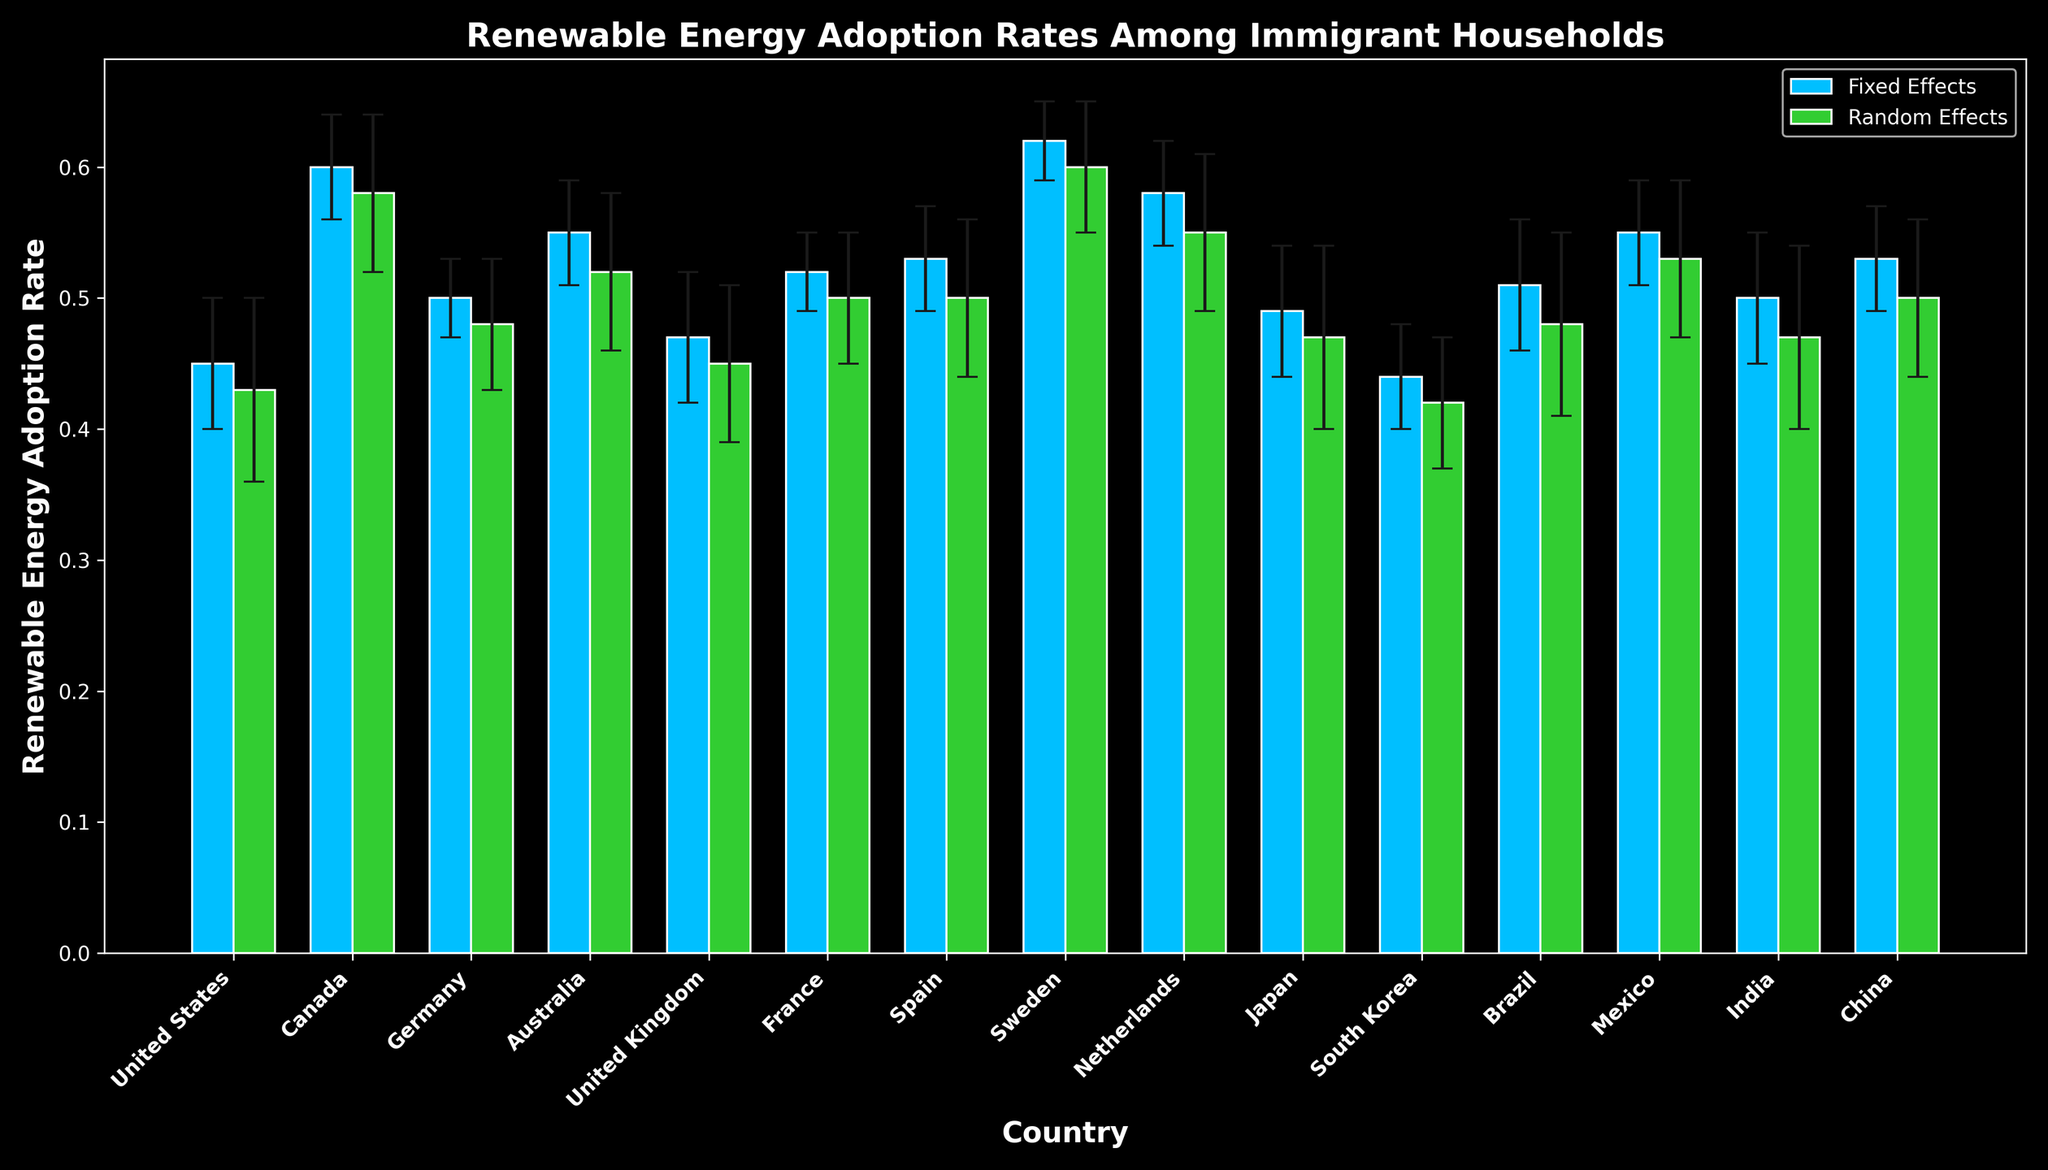Which country has the highest renewable energy adoption rate among immigrant households according to the fixed effects model? By looking at the heights of the blue bars representing the fixed effects model, Sweden has the highest bar around 0.62 according to the fixed effects model.
Answer: Sweden Which country has the smallest difference in renewable energy adoption rate between the fixed effects and random effects models? The differences between the bars can be observed, and Canada has the smallest difference as the fixed effects adoption rate is 0.60 and the random effects adoption rate is 0.58, giving a difference of 0.02.
Answer: Canada Between France and Germany, which country has a higher adoption rate according to the random effects model? Looking at the heights of the green bars for France and Germany, France has a slightly higher adoption rate of 0.50 compared to Germany's 0.48 in the random effects model.
Answer: France Calculate the average fixed effects adoption rate for Canada, Germany, and Australia. The fixed effects rates for Canada, Germany, and Australia are 0.60, 0.50, and 0.55 respectively. The average is (0.60 + 0.50 + 0.55) / 3 = 0.55.
Answer: 0.55 How does the error margin for the fixed effects model for Sweden compare to the error margin for the random effects model for the United States? The error margin for Sweden's fixed effects model is 0.03 and for the United States' random effects model is 0.07. By comparing these values, it is clear that Sweden's fixed effects model has a smaller error margin.
Answer: Sweden's fixed effects model has a smaller error margin Which country shows the largest difference in error margins between the fixed effects and random effects models? By examining the data, the United States shows the largest difference in error margins: fixed effects error is 0.05 and random effects error is 0.07, giving a difference of 0.02.
Answer: United States Among Mexico, China, and India, which country has the highest average adoption rate across both models? The average adoption rates can be calculated: Mexico (0.55 + 0.53) / 2 = 0.54, China (0.53 + 0.50) / 2 = 0.515, India (0.50 + 0.47) / 2 = 0.485. Mexico has the highest average.
Answer: Mexico Which two countries have error margins below 0.05 in both the fixed effects and random effects models? The countries that meet this criterion can be checked: Germany, France, and Sweden all have error margins below 0.05 in both models.
Answer: Germany, France, Sweden For the fixed effects model, what is the difference in adoption rates between the country with the highest rate and the one with the lowest rate? The highest fixed effects rate is Sweden at 0.62, and the lowest is South Korea at 0.44. The difference is 0.62 - 0.44 = 0.18.
Answer: 0.18 